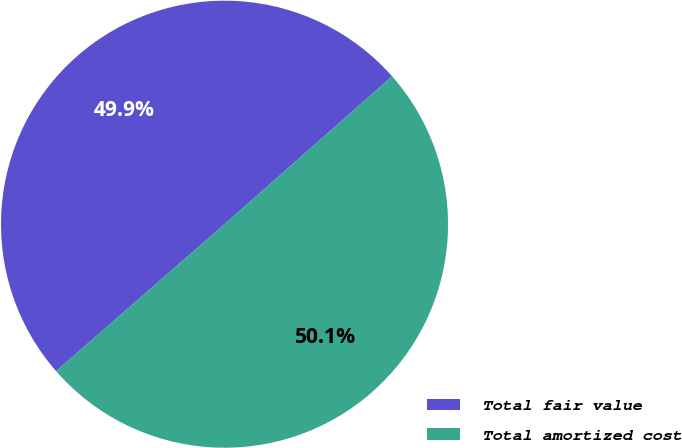Convert chart to OTSL. <chart><loc_0><loc_0><loc_500><loc_500><pie_chart><fcel>Total fair value<fcel>Total amortized cost<nl><fcel>49.91%<fcel>50.09%<nl></chart> 